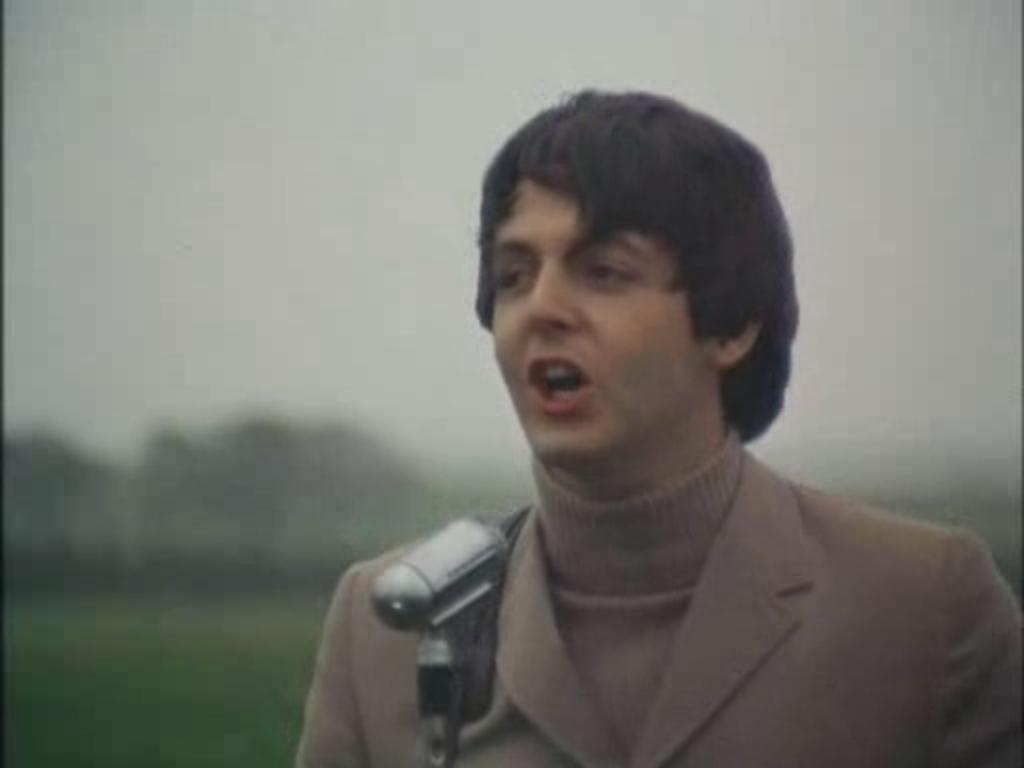How would you summarize this image in a sentence or two? In this image there is a man with brown jacket is speaking in a microphone. 